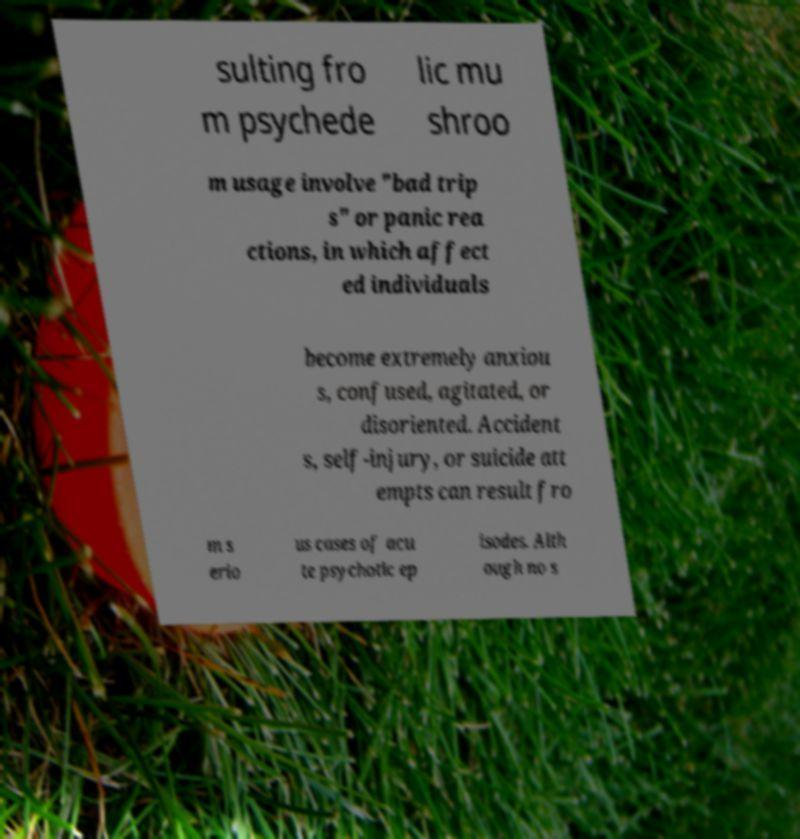I need the written content from this picture converted into text. Can you do that? sulting fro m psychede lic mu shroo m usage involve "bad trip s" or panic rea ctions, in which affect ed individuals become extremely anxiou s, confused, agitated, or disoriented. Accident s, self-injury, or suicide att empts can result fro m s erio us cases of acu te psychotic ep isodes. Alth ough no s 